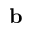Convert formula to latex. <formula><loc_0><loc_0><loc_500><loc_500>b</formula> 